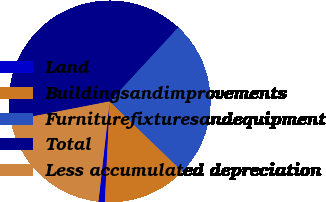Convert chart. <chart><loc_0><loc_0><loc_500><loc_500><pie_chart><fcel>Land<fcel>Buildingsandimprovements<fcel>Furniturefixturesandequipment<fcel>Total<fcel>Less accumulated depreciation<nl><fcel>1.02%<fcel>13.56%<fcel>25.34%<fcel>39.92%<fcel>20.16%<nl></chart> 